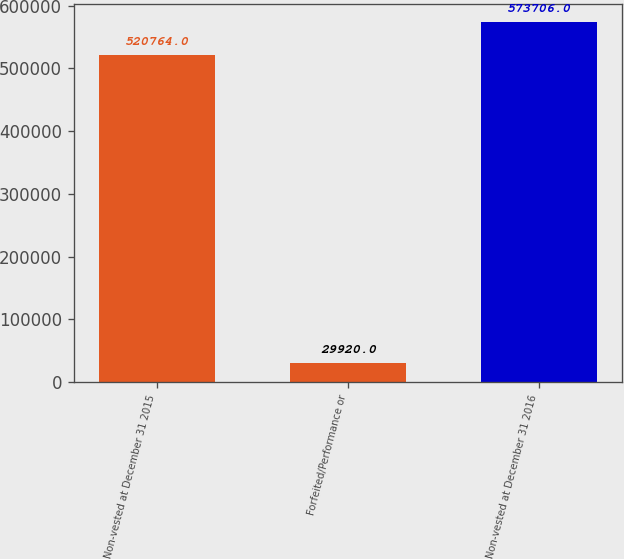<chart> <loc_0><loc_0><loc_500><loc_500><bar_chart><fcel>Non-vested at December 31 2015<fcel>Forfeited/Performance or<fcel>Non-vested at December 31 2016<nl><fcel>520764<fcel>29920<fcel>573706<nl></chart> 